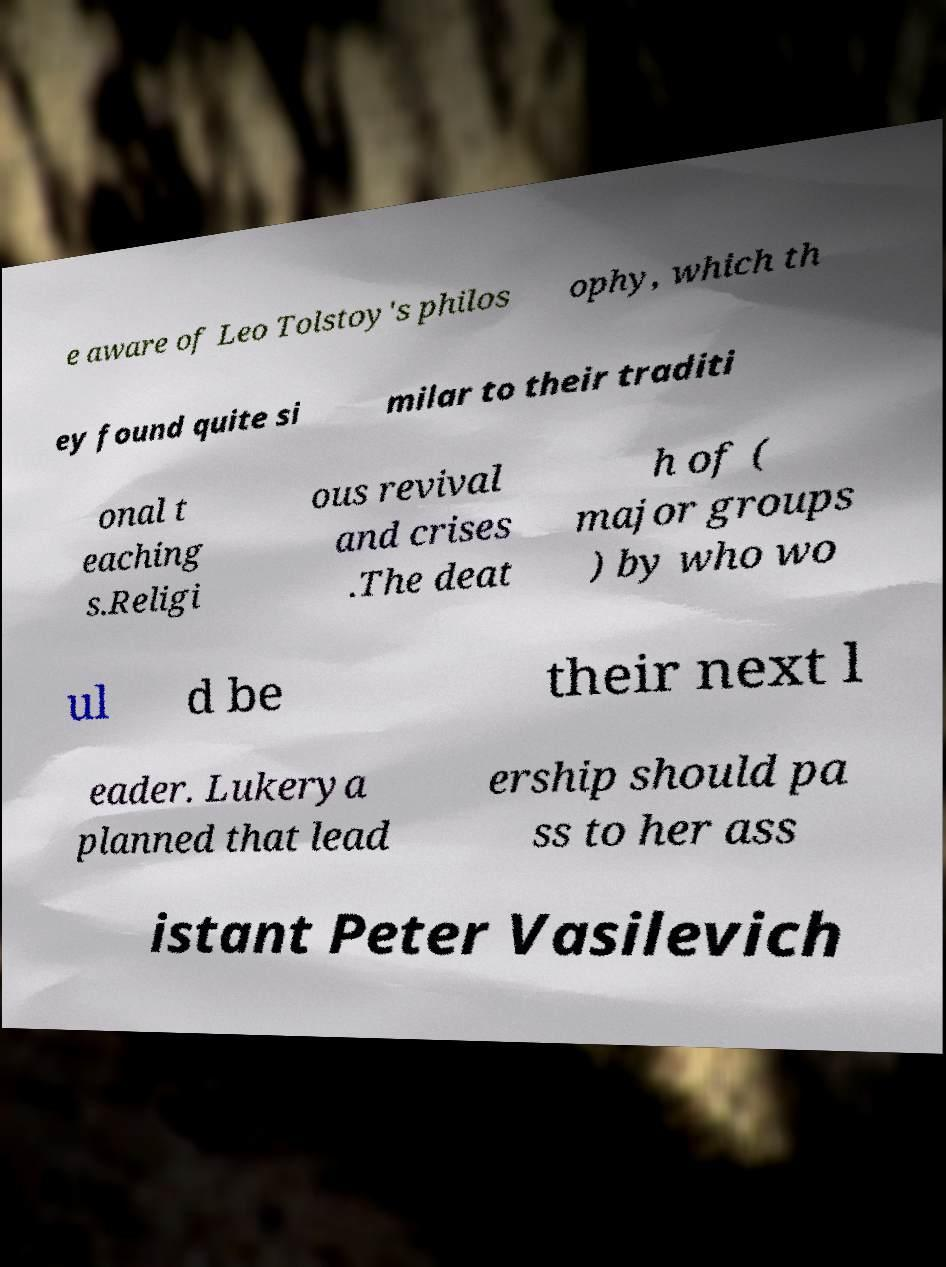Please identify and transcribe the text found in this image. e aware of Leo Tolstoy's philos ophy, which th ey found quite si milar to their traditi onal t eaching s.Religi ous revival and crises .The deat h of ( major groups ) by who wo ul d be their next l eader. Lukerya planned that lead ership should pa ss to her ass istant Peter Vasilevich 